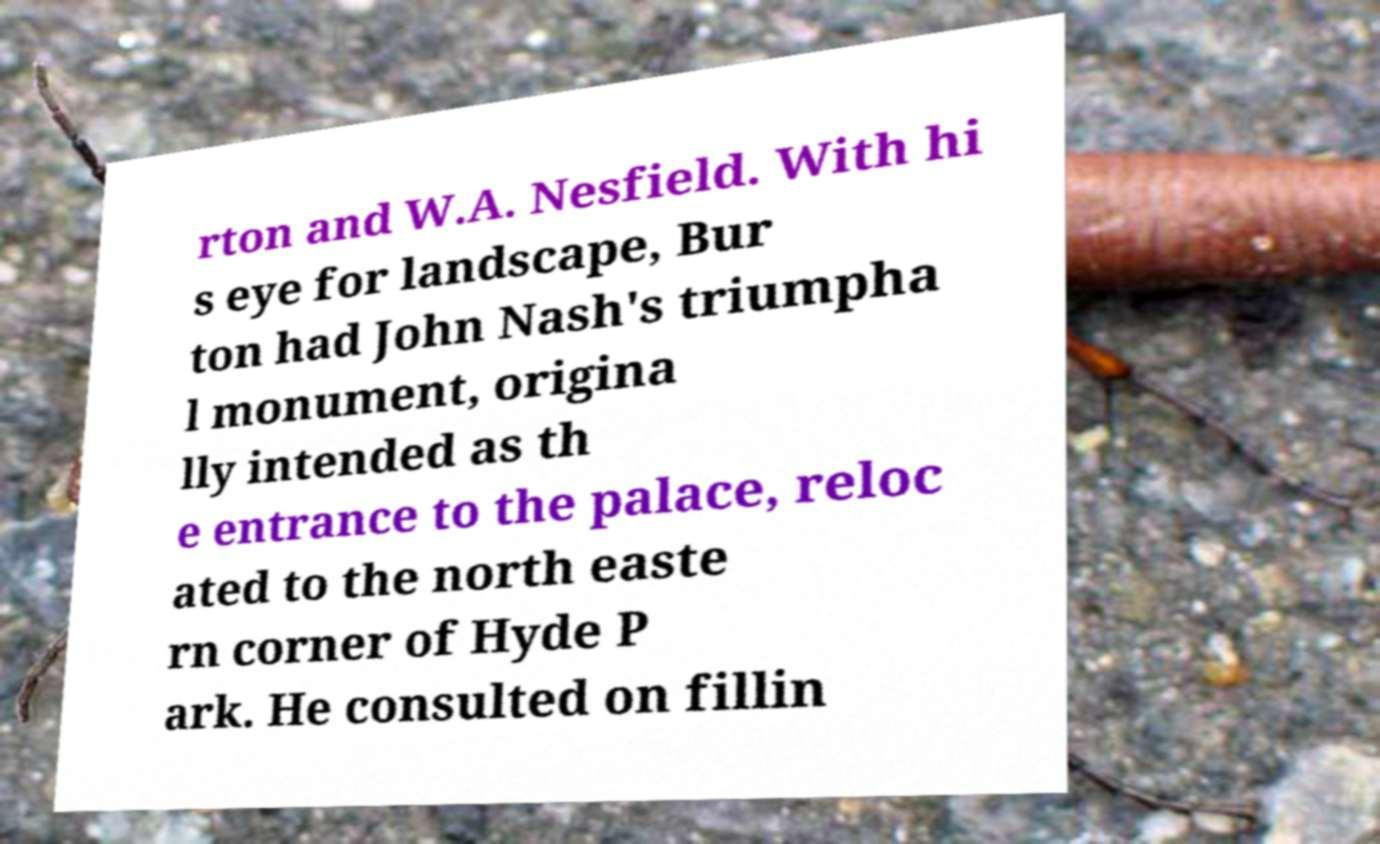Can you read and provide the text displayed in the image?This photo seems to have some interesting text. Can you extract and type it out for me? rton and W.A. Nesfield. With hi s eye for landscape, Bur ton had John Nash's triumpha l monument, origina lly intended as th e entrance to the palace, reloc ated to the north easte rn corner of Hyde P ark. He consulted on fillin 